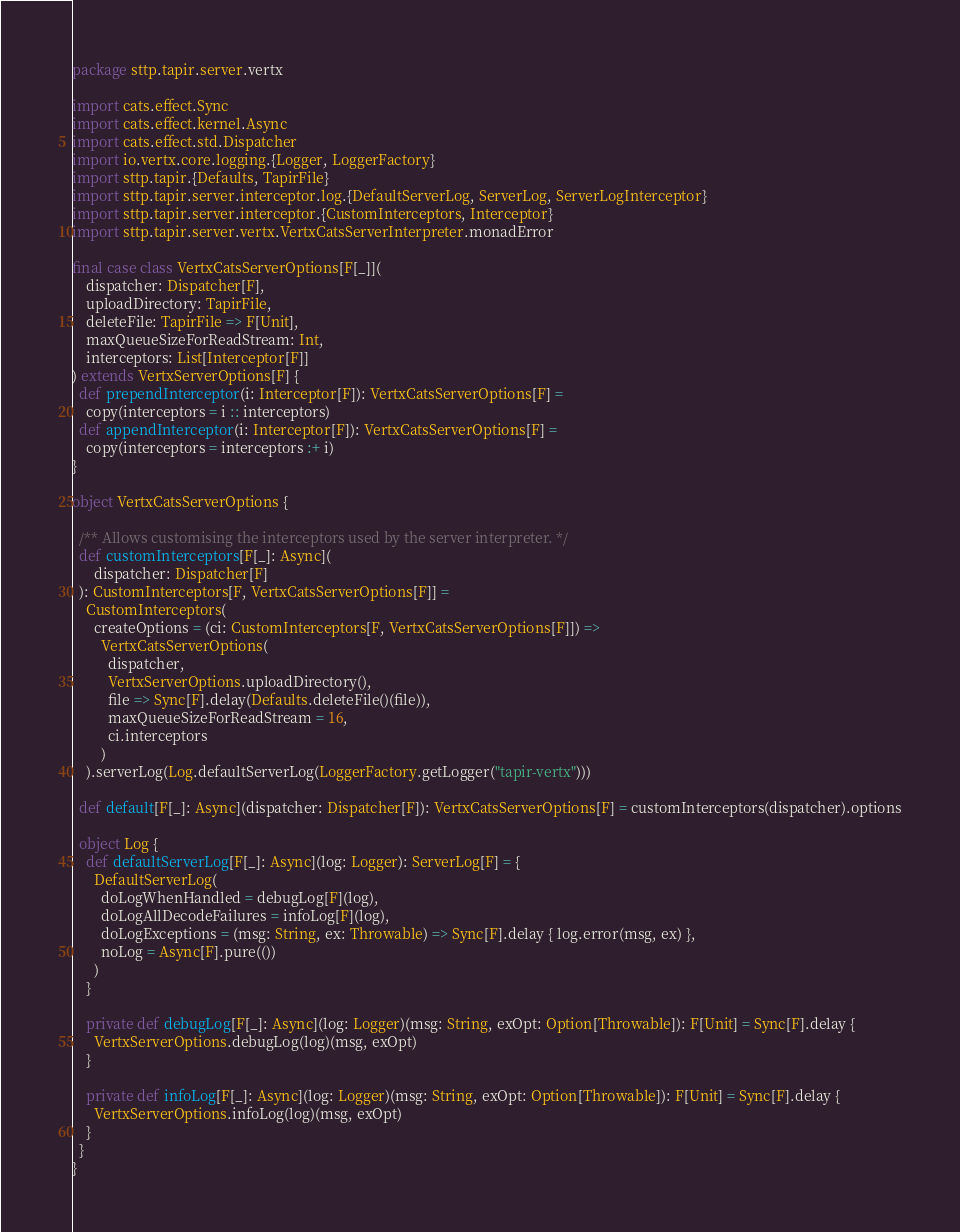Convert code to text. <code><loc_0><loc_0><loc_500><loc_500><_Scala_>package sttp.tapir.server.vertx

import cats.effect.Sync
import cats.effect.kernel.Async
import cats.effect.std.Dispatcher
import io.vertx.core.logging.{Logger, LoggerFactory}
import sttp.tapir.{Defaults, TapirFile}
import sttp.tapir.server.interceptor.log.{DefaultServerLog, ServerLog, ServerLogInterceptor}
import sttp.tapir.server.interceptor.{CustomInterceptors, Interceptor}
import sttp.tapir.server.vertx.VertxCatsServerInterpreter.monadError

final case class VertxCatsServerOptions[F[_]](
    dispatcher: Dispatcher[F],
    uploadDirectory: TapirFile,
    deleteFile: TapirFile => F[Unit],
    maxQueueSizeForReadStream: Int,
    interceptors: List[Interceptor[F]]
) extends VertxServerOptions[F] {
  def prependInterceptor(i: Interceptor[F]): VertxCatsServerOptions[F] =
    copy(interceptors = i :: interceptors)
  def appendInterceptor(i: Interceptor[F]): VertxCatsServerOptions[F] =
    copy(interceptors = interceptors :+ i)
}

object VertxCatsServerOptions {

  /** Allows customising the interceptors used by the server interpreter. */
  def customInterceptors[F[_]: Async](
      dispatcher: Dispatcher[F]
  ): CustomInterceptors[F, VertxCatsServerOptions[F]] =
    CustomInterceptors(
      createOptions = (ci: CustomInterceptors[F, VertxCatsServerOptions[F]]) =>
        VertxCatsServerOptions(
          dispatcher,
          VertxServerOptions.uploadDirectory(),
          file => Sync[F].delay(Defaults.deleteFile()(file)),
          maxQueueSizeForReadStream = 16,
          ci.interceptors
        )
    ).serverLog(Log.defaultServerLog(LoggerFactory.getLogger("tapir-vertx")))

  def default[F[_]: Async](dispatcher: Dispatcher[F]): VertxCatsServerOptions[F] = customInterceptors(dispatcher).options

  object Log {
    def defaultServerLog[F[_]: Async](log: Logger): ServerLog[F] = {
      DefaultServerLog(
        doLogWhenHandled = debugLog[F](log),
        doLogAllDecodeFailures = infoLog[F](log),
        doLogExceptions = (msg: String, ex: Throwable) => Sync[F].delay { log.error(msg, ex) },
        noLog = Async[F].pure(())
      )
    }

    private def debugLog[F[_]: Async](log: Logger)(msg: String, exOpt: Option[Throwable]): F[Unit] = Sync[F].delay {
      VertxServerOptions.debugLog(log)(msg, exOpt)
    }

    private def infoLog[F[_]: Async](log: Logger)(msg: String, exOpt: Option[Throwable]): F[Unit] = Sync[F].delay {
      VertxServerOptions.infoLog(log)(msg, exOpt)
    }
  }
}
</code> 